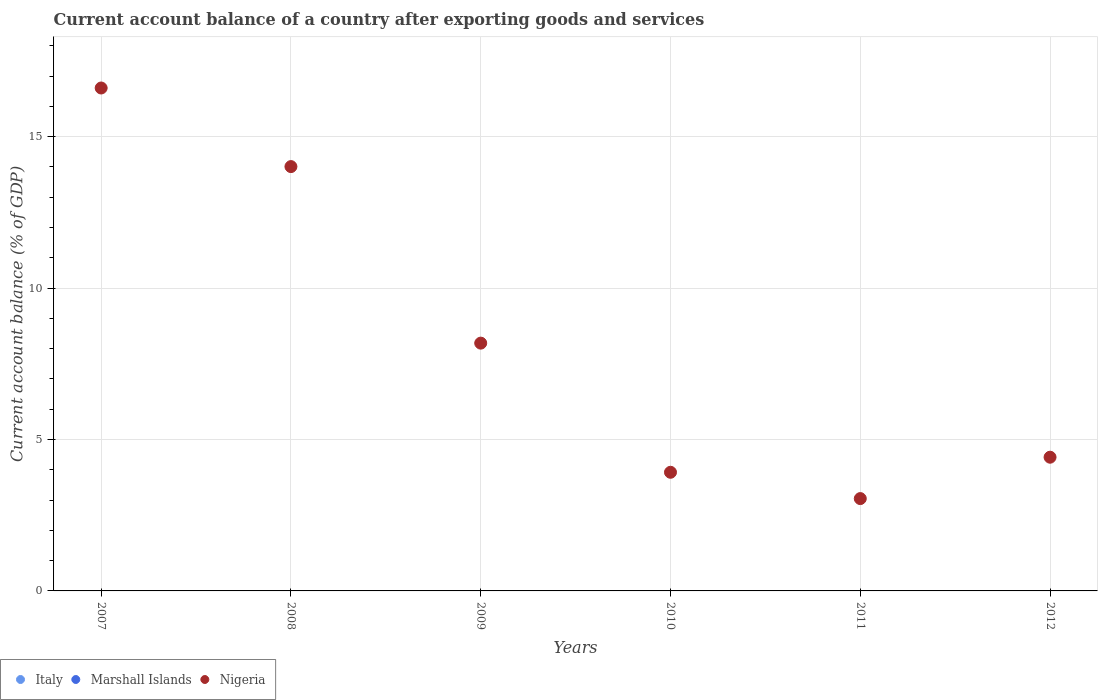What is the account balance in Nigeria in 2011?
Give a very brief answer. 3.05. Across all years, what is the maximum account balance in Nigeria?
Give a very brief answer. 16.61. In which year was the account balance in Nigeria maximum?
Make the answer very short. 2007. What is the total account balance in Nigeria in the graph?
Provide a succinct answer. 50.18. What is the difference between the account balance in Nigeria in 2008 and that in 2012?
Your response must be concise. 9.6. What is the difference between the account balance in Nigeria in 2011 and the account balance in Italy in 2008?
Your response must be concise. 3.05. What is the average account balance in Italy per year?
Make the answer very short. 0. What is the ratio of the account balance in Nigeria in 2008 to that in 2009?
Offer a terse response. 1.71. What is the difference between the highest and the lowest account balance in Nigeria?
Offer a terse response. 13.56. Is the account balance in Marshall Islands strictly greater than the account balance in Nigeria over the years?
Provide a succinct answer. No. How many dotlines are there?
Give a very brief answer. 1. How many years are there in the graph?
Ensure brevity in your answer.  6. What is the difference between two consecutive major ticks on the Y-axis?
Ensure brevity in your answer.  5. Does the graph contain any zero values?
Offer a terse response. Yes. Does the graph contain grids?
Offer a terse response. Yes. Where does the legend appear in the graph?
Provide a succinct answer. Bottom left. What is the title of the graph?
Your answer should be compact. Current account balance of a country after exporting goods and services. Does "Middle East & North Africa (all income levels)" appear as one of the legend labels in the graph?
Ensure brevity in your answer.  No. What is the label or title of the Y-axis?
Provide a short and direct response. Current account balance (% of GDP). What is the Current account balance (% of GDP) in Nigeria in 2007?
Keep it short and to the point. 16.61. What is the Current account balance (% of GDP) in Italy in 2008?
Offer a very short reply. 0. What is the Current account balance (% of GDP) in Marshall Islands in 2008?
Your answer should be compact. 0. What is the Current account balance (% of GDP) of Nigeria in 2008?
Offer a very short reply. 14.01. What is the Current account balance (% of GDP) in Italy in 2009?
Provide a succinct answer. 0. What is the Current account balance (% of GDP) in Nigeria in 2009?
Keep it short and to the point. 8.18. What is the Current account balance (% of GDP) of Marshall Islands in 2010?
Your answer should be compact. 0. What is the Current account balance (% of GDP) of Nigeria in 2010?
Your answer should be very brief. 3.92. What is the Current account balance (% of GDP) of Italy in 2011?
Offer a terse response. 0. What is the Current account balance (% of GDP) of Marshall Islands in 2011?
Offer a terse response. 0. What is the Current account balance (% of GDP) in Nigeria in 2011?
Provide a succinct answer. 3.05. What is the Current account balance (% of GDP) of Italy in 2012?
Your answer should be compact. 0. What is the Current account balance (% of GDP) in Nigeria in 2012?
Make the answer very short. 4.42. Across all years, what is the maximum Current account balance (% of GDP) of Nigeria?
Keep it short and to the point. 16.61. Across all years, what is the minimum Current account balance (% of GDP) in Nigeria?
Provide a succinct answer. 3.05. What is the total Current account balance (% of GDP) of Nigeria in the graph?
Your answer should be compact. 50.18. What is the difference between the Current account balance (% of GDP) of Nigeria in 2007 and that in 2008?
Make the answer very short. 2.6. What is the difference between the Current account balance (% of GDP) in Nigeria in 2007 and that in 2009?
Offer a terse response. 8.43. What is the difference between the Current account balance (% of GDP) in Nigeria in 2007 and that in 2010?
Your answer should be compact. 12.69. What is the difference between the Current account balance (% of GDP) of Nigeria in 2007 and that in 2011?
Give a very brief answer. 13.56. What is the difference between the Current account balance (% of GDP) in Nigeria in 2007 and that in 2012?
Provide a short and direct response. 12.19. What is the difference between the Current account balance (% of GDP) of Nigeria in 2008 and that in 2009?
Provide a short and direct response. 5.83. What is the difference between the Current account balance (% of GDP) in Nigeria in 2008 and that in 2010?
Provide a succinct answer. 10.09. What is the difference between the Current account balance (% of GDP) of Nigeria in 2008 and that in 2011?
Your response must be concise. 10.96. What is the difference between the Current account balance (% of GDP) in Nigeria in 2008 and that in 2012?
Provide a short and direct response. 9.6. What is the difference between the Current account balance (% of GDP) of Nigeria in 2009 and that in 2010?
Your answer should be very brief. 4.26. What is the difference between the Current account balance (% of GDP) of Nigeria in 2009 and that in 2011?
Offer a terse response. 5.13. What is the difference between the Current account balance (% of GDP) in Nigeria in 2009 and that in 2012?
Make the answer very short. 3.77. What is the difference between the Current account balance (% of GDP) of Nigeria in 2010 and that in 2011?
Your response must be concise. 0.87. What is the difference between the Current account balance (% of GDP) of Nigeria in 2010 and that in 2012?
Give a very brief answer. -0.5. What is the difference between the Current account balance (% of GDP) in Nigeria in 2011 and that in 2012?
Your response must be concise. -1.37. What is the average Current account balance (% of GDP) of Italy per year?
Provide a short and direct response. 0. What is the average Current account balance (% of GDP) in Nigeria per year?
Give a very brief answer. 8.36. What is the ratio of the Current account balance (% of GDP) of Nigeria in 2007 to that in 2008?
Make the answer very short. 1.19. What is the ratio of the Current account balance (% of GDP) in Nigeria in 2007 to that in 2009?
Keep it short and to the point. 2.03. What is the ratio of the Current account balance (% of GDP) in Nigeria in 2007 to that in 2010?
Offer a very short reply. 4.24. What is the ratio of the Current account balance (% of GDP) in Nigeria in 2007 to that in 2011?
Your response must be concise. 5.45. What is the ratio of the Current account balance (% of GDP) of Nigeria in 2007 to that in 2012?
Your answer should be very brief. 3.76. What is the ratio of the Current account balance (% of GDP) in Nigeria in 2008 to that in 2009?
Offer a very short reply. 1.71. What is the ratio of the Current account balance (% of GDP) of Nigeria in 2008 to that in 2010?
Ensure brevity in your answer.  3.58. What is the ratio of the Current account balance (% of GDP) in Nigeria in 2008 to that in 2011?
Ensure brevity in your answer.  4.6. What is the ratio of the Current account balance (% of GDP) in Nigeria in 2008 to that in 2012?
Provide a short and direct response. 3.17. What is the ratio of the Current account balance (% of GDP) in Nigeria in 2009 to that in 2010?
Ensure brevity in your answer.  2.09. What is the ratio of the Current account balance (% of GDP) of Nigeria in 2009 to that in 2011?
Keep it short and to the point. 2.68. What is the ratio of the Current account balance (% of GDP) in Nigeria in 2009 to that in 2012?
Your response must be concise. 1.85. What is the ratio of the Current account balance (% of GDP) of Nigeria in 2010 to that in 2011?
Offer a very short reply. 1.28. What is the ratio of the Current account balance (% of GDP) in Nigeria in 2010 to that in 2012?
Keep it short and to the point. 0.89. What is the ratio of the Current account balance (% of GDP) of Nigeria in 2011 to that in 2012?
Make the answer very short. 0.69. What is the difference between the highest and the second highest Current account balance (% of GDP) in Nigeria?
Keep it short and to the point. 2.6. What is the difference between the highest and the lowest Current account balance (% of GDP) in Nigeria?
Your response must be concise. 13.56. 